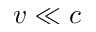Convert formula to latex. <formula><loc_0><loc_0><loc_500><loc_500>v \ll c</formula> 